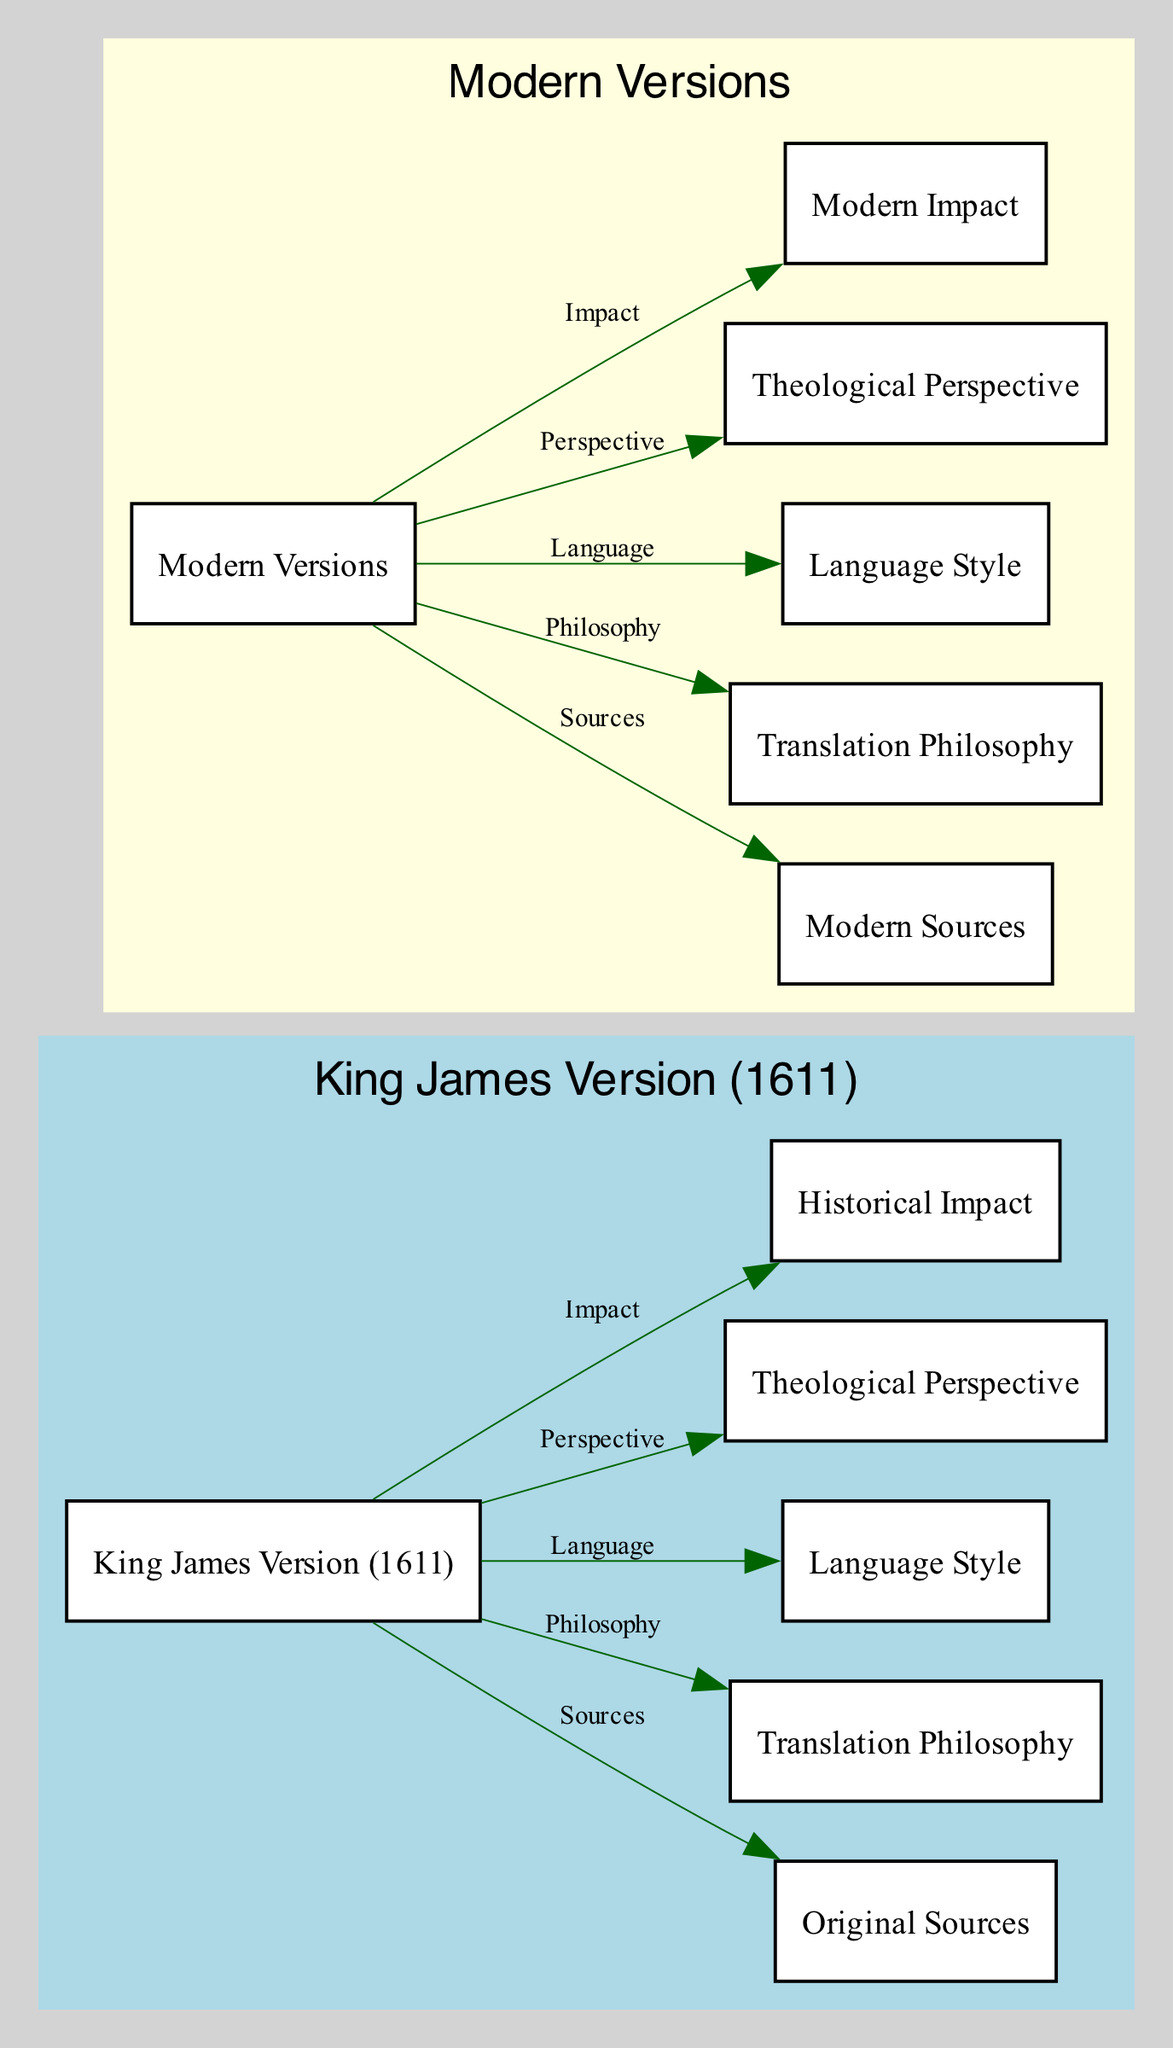What does "KJV" stand for? The node labeled "KJV" corresponds to the "King James Version (1611)." This can be directly identified from the node's label in the diagram.
Answer: King James Version (1611) What type of sources does the King James Version rely on? The edge labeled "Sources" connecting "KJV" to "Original Sources" indicates that the King James Version is based on original sources. Thus, this relationship highlights the foundational aspect of its translation.
Answer: Original Sources How many impact nodes are shown in the diagram? The diagram shows two impact nodes: one for "KJV" and one for "Modern Impact." Counting these nodes provides the answer.
Answer: 2 What is the language style of modern versions? The node labeled "modernLanguageStyle" provides this information directly, indicating that modern versions have a specific language style. The explanation can refer to the node's label.
Answer: Language Style Which translation philosophy aligns with modern versions? The edge from "modernVersions" to "modernTranslationPhilosophy" labelled "Philosophy" signifies the philosophical approach modern versions take. The answer can be found by identifying the connection indicated by the edge.
Answer: Translation Philosophy What is a theological perspective associated with the King James Version? The edge labeled "Perspective" connecting "KJV" to "kjvTheologicalPerspective" indicates that there is a specific theological perspective associated with the King James Version. This connection allows us to answer the question based on the provided diagram structure.
Answer: Theological Perspective Which version has a greater historical impact? The edge labeled "Impact" shows the connection from "KJV" to "kjvImpact" and "modernVersions" to "modernImpact." However, "kjvImpact" is often historically significant compared to modern impacts. Through this comparison, we arrive at the conclusion.
Answer: Historical Impact What do modern versions primarily rely on for their sources? The edge labeled "Sources" from "modernVersions" to "modernSource" indicates that modern versions are based on modern sources. This answer is straightforward as it comes from a directly labeled edge in the diagram.
Answer: Modern Sources What translation philosophy is associated with the King James Version? The edge labeled "Philosophy" connects "KJV" to "kjvTranslationPhilosophy," which shows the specific translation philosophy that the King James Version adheres to. Thus, it's accessible directly from the diagram's connections.
Answer: Translation Philosophy 